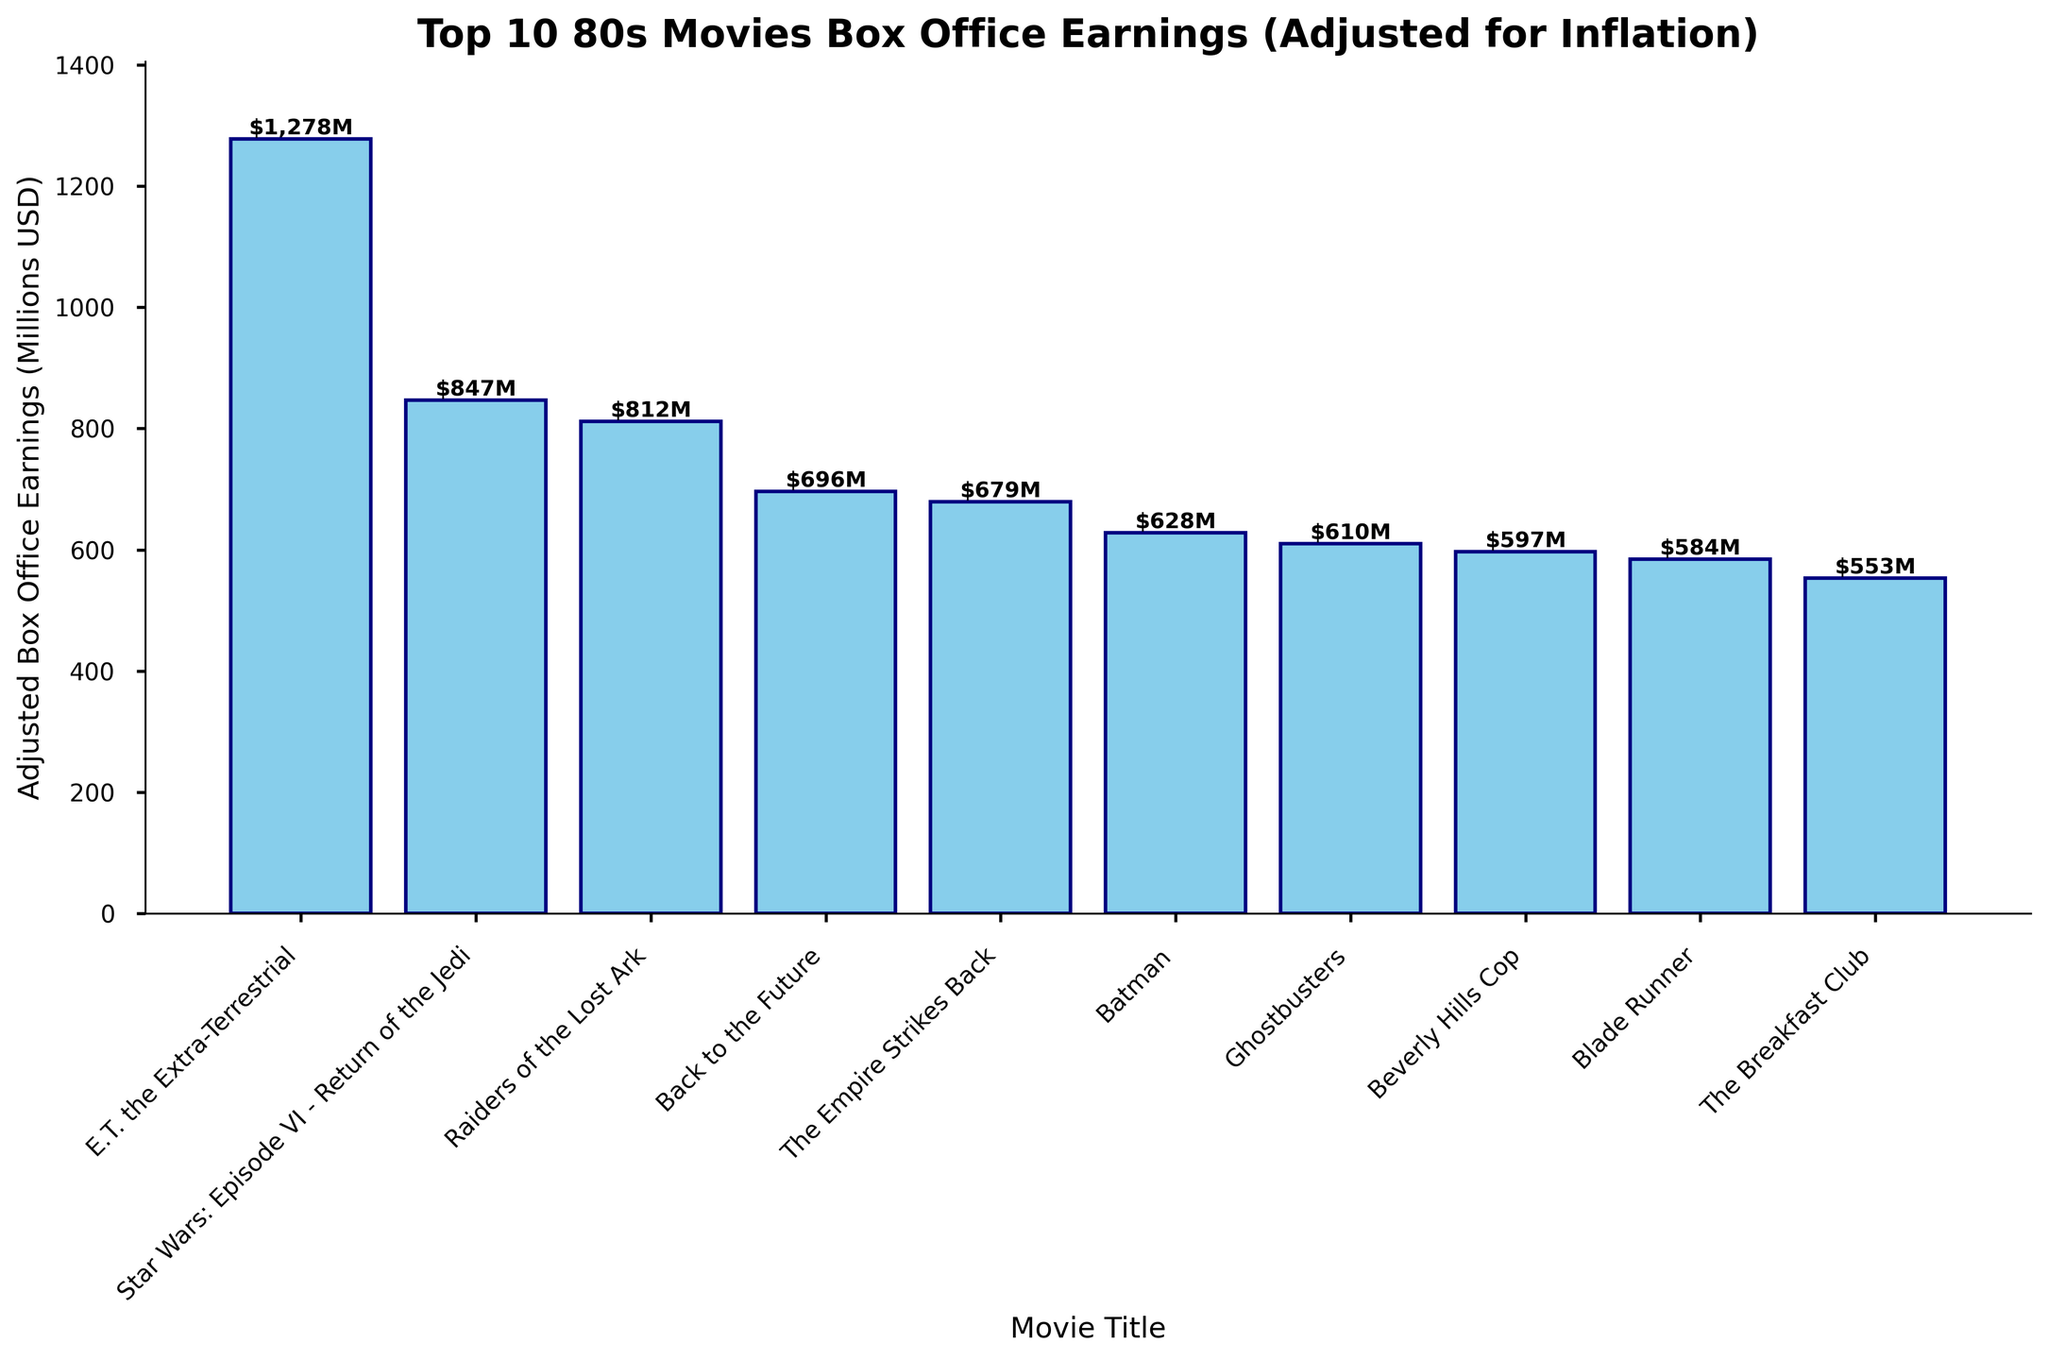Which movie had the highest adjusted box office earnings? The tallest bar in the chart represents the movie with the highest earnings. By comparing the bar heights, we see "E.T. the Extra-Terrestrial" has the highest bar.
Answer: E.T. the Extra-Terrestrial Which movie earned more, "Ghostbusters" or "The Breakfast Club"? Comparing the bars for "Ghostbusters" and "The Breakfast Club," the bar for "Ghostbusters" is taller. Therefore, "Ghostbusters" earned more.
Answer: Ghostbusters What is the sum of the adjusted box office earnings of "Batman" and "Beverly Hills Cop"? "Batman" earned $628M and "Beverly Hills Cop" earned $597M. Adding these, $628M + $597M = $1225M.
Answer: $1225M Which movies earned roughly the same adjusted box office amount? "Blade Runner" and "The Breakfast Club" have bars of similar height. Checking the exact values, "Blade Runner" earned $584M, and "The Breakfast Club" earned $553M, which are close.
Answer: Blade Runner and The Breakfast Club How much more did "E.T. the Extra-Terrestrial" earn compared to "The Empire Strikes Back"? "E.T. the Extra-Terrestrial" earned $1278M and "The Empire Strikes Back" earned $679M. The difference is $1278M - $679M = $599M.
Answer: $599M Which is the third highest-grossing movie? The third tallest bar will represent the third highest. Upon inspection, "Raiders of the Lost Ark" is the third tallest bar.
Answer: Raiders of the Lost Ark Which movie earned the least adjusted box office earnings? The shortest bar represents the movie with the least earnings. By checking the shortest bar, "The Breakfast Club" has the lowest earnings.
Answer: The Breakfast Club What is the average adjusted box office earnings of the top 3 earning movies? The top 3 earning movies are "E.T. the Extra-Terrestrial" ($1278M), "Star Wars: Episode VI - Return of the Jedi" ($847M), and "Raiders of the Lost Ark" ($812M). The sum is $1278M + $847M + $812M = $2937M. The average is $2937M / 3 = $979M.
Answer: $979M How many movies earned more than $600M? By examining the bars above the $600M mark, "E.T. the Extra-Terrestrial," "Star Wars: Episode VI - Return of the Jedi," "Raiders of the Lost Ark," "Back to the Future," "The Empire Strikes Back," "Batman," and "Ghostbusters" all earned more than $600M.
Answer: 7 